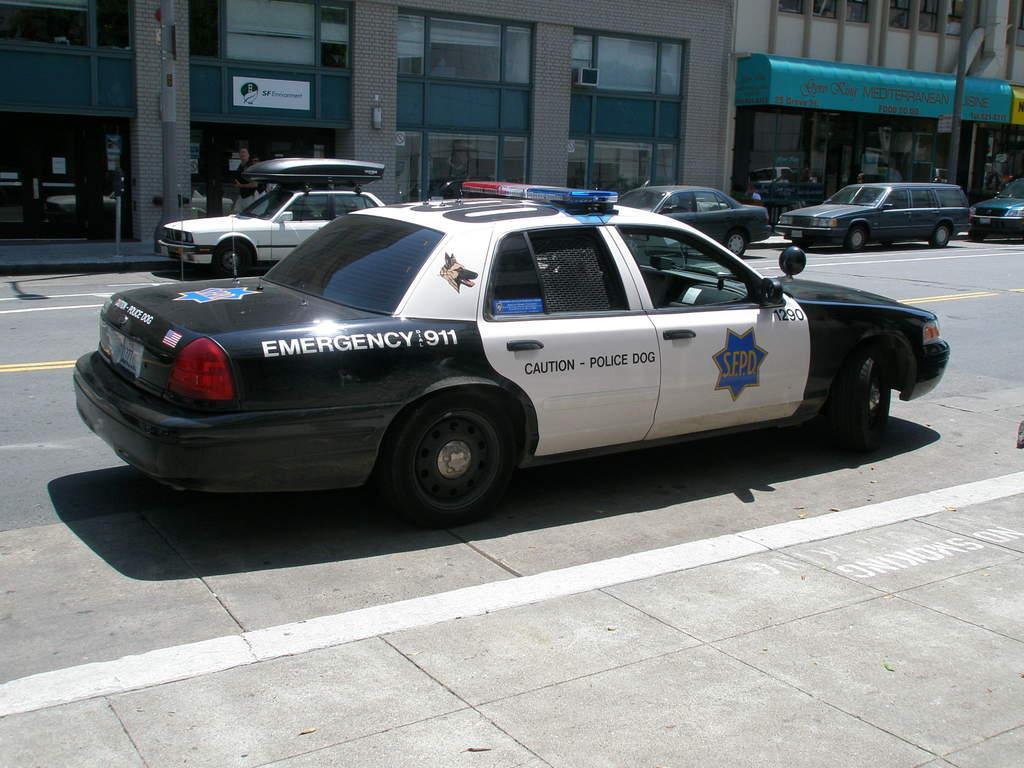Could you give a brief overview of what you see in this image? In the center of the image, we can see vehicles on the road and in the background, there are buildings and poles. 